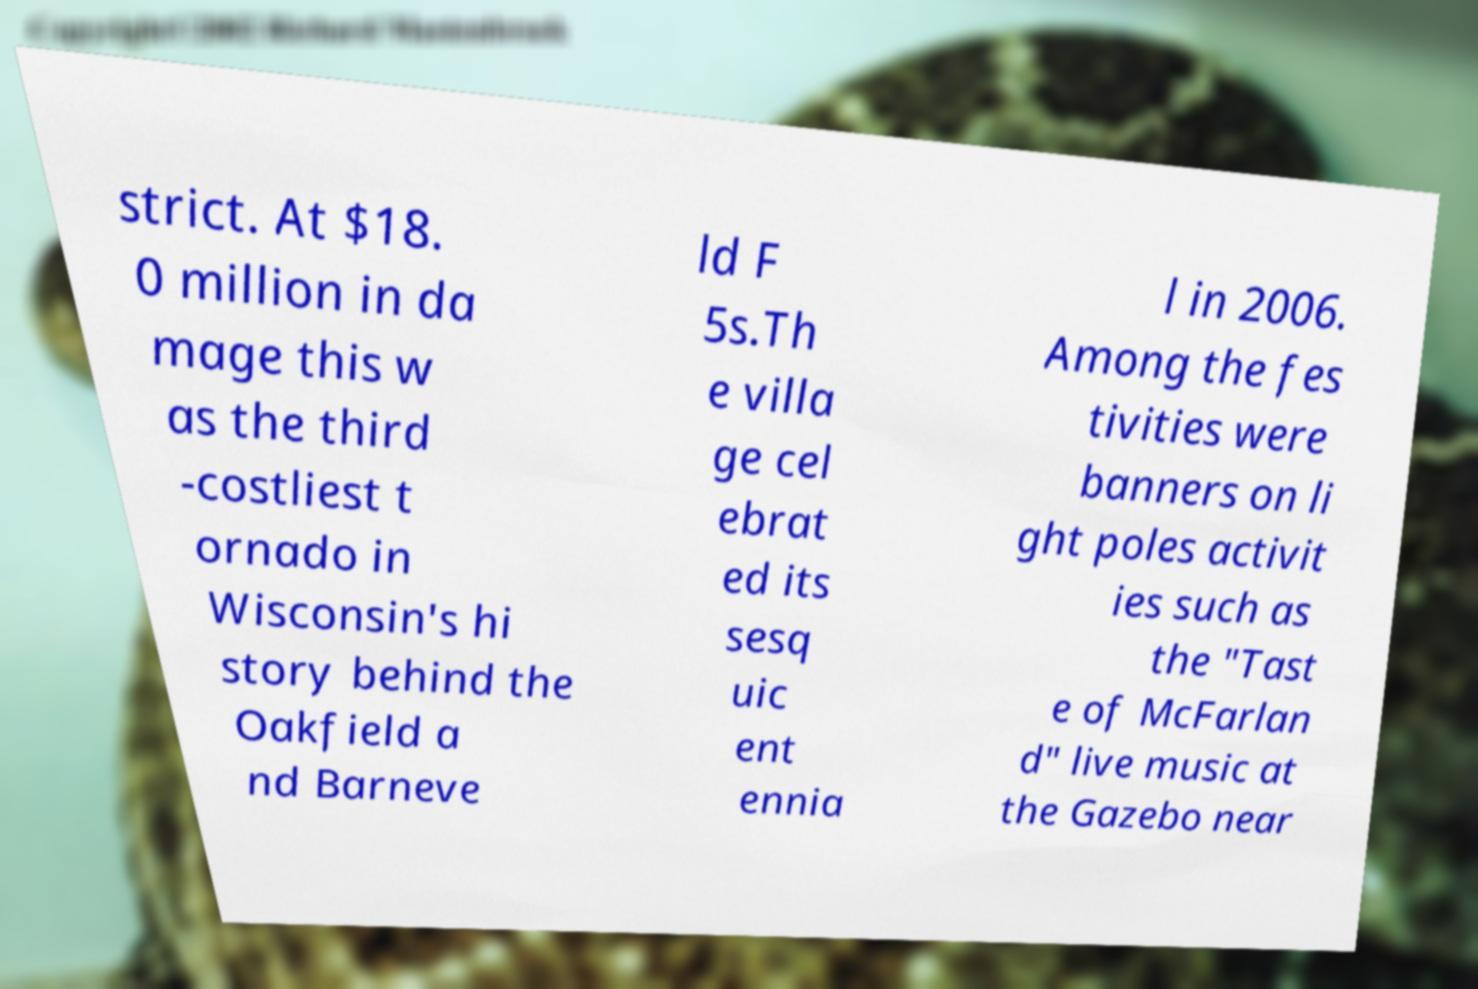Could you assist in decoding the text presented in this image and type it out clearly? strict. At $18. 0 million in da mage this w as the third -costliest t ornado in Wisconsin's hi story behind the Oakfield a nd Barneve ld F 5s.Th e villa ge cel ebrat ed its sesq uic ent ennia l in 2006. Among the fes tivities were banners on li ght poles activit ies such as the "Tast e of McFarlan d" live music at the Gazebo near 